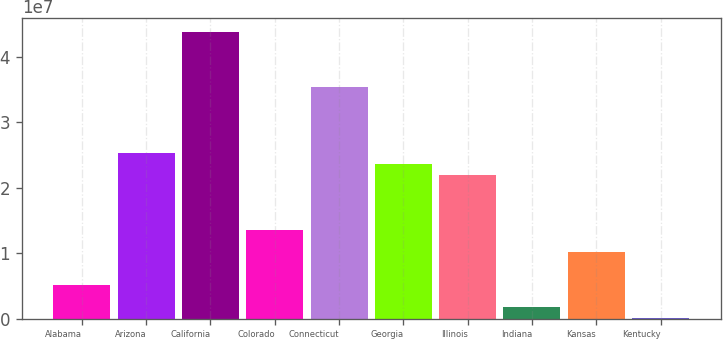Convert chart to OTSL. <chart><loc_0><loc_0><loc_500><loc_500><bar_chart><fcel>Alabama<fcel>Arizona<fcel>California<fcel>Colorado<fcel>Connecticut<fcel>Georgia<fcel>Illinois<fcel>Indiana<fcel>Kansas<fcel>Kentucky<nl><fcel>5.09209e+06<fcel>2.52559e+07<fcel>4.37395e+07<fcel>1.34937e+07<fcel>3.53379e+07<fcel>2.35756e+07<fcel>2.18953e+07<fcel>1.73145e+06<fcel>1.01331e+07<fcel>51128<nl></chart> 